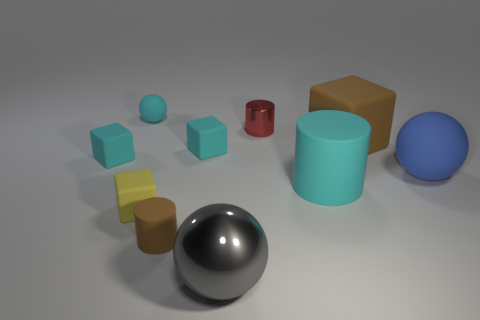Subtract all cylinders. How many objects are left? 7 Add 8 large green shiny objects. How many large green shiny objects exist? 8 Subtract 0 red spheres. How many objects are left? 10 Subtract all tiny cylinders. Subtract all blue objects. How many objects are left? 7 Add 2 shiny balls. How many shiny balls are left? 3 